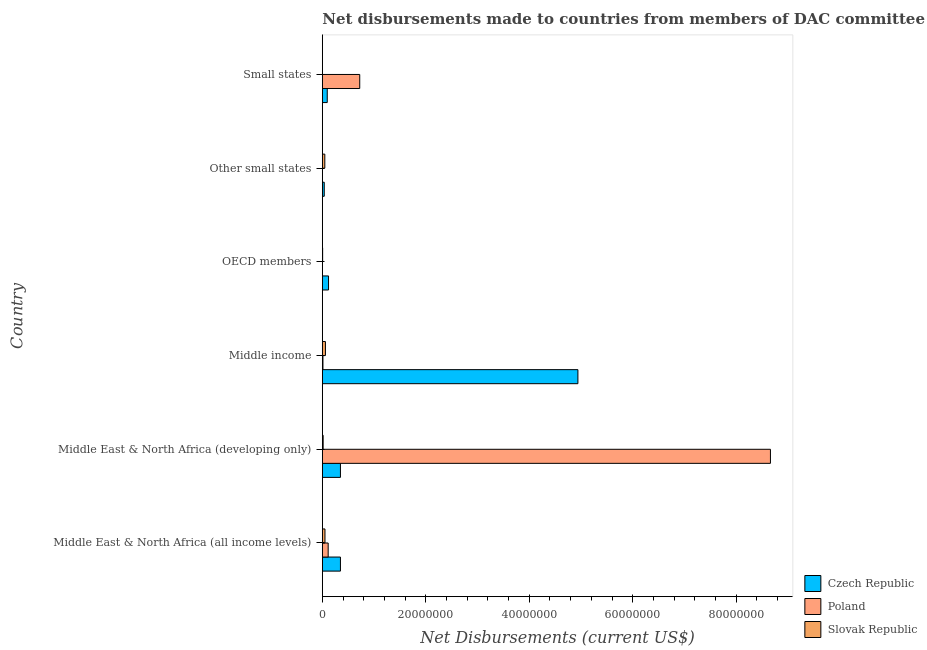How many groups of bars are there?
Your answer should be very brief. 6. Are the number of bars per tick equal to the number of legend labels?
Offer a terse response. No. What is the label of the 5th group of bars from the top?
Make the answer very short. Middle East & North Africa (developing only). In how many cases, is the number of bars for a given country not equal to the number of legend labels?
Your answer should be compact. 2. What is the net disbursements made by slovak republic in Middle East & North Africa (developing only)?
Ensure brevity in your answer.  1.60e+05. Across all countries, what is the maximum net disbursements made by poland?
Give a very brief answer. 8.66e+07. Across all countries, what is the minimum net disbursements made by czech republic?
Provide a succinct answer. 3.70e+05. In which country was the net disbursements made by czech republic maximum?
Provide a succinct answer. Middle income. What is the total net disbursements made by czech republic in the graph?
Make the answer very short. 5.89e+07. What is the difference between the net disbursements made by slovak republic in Middle East & North Africa (all income levels) and that in Small states?
Keep it short and to the point. 4.80e+05. What is the difference between the net disbursements made by poland in Small states and the net disbursements made by slovak republic in Other small states?
Provide a succinct answer. 6.75e+06. What is the average net disbursements made by czech republic per country?
Keep it short and to the point. 9.82e+06. What is the difference between the net disbursements made by slovak republic and net disbursements made by czech republic in Other small states?
Give a very brief answer. 1.10e+05. In how many countries, is the net disbursements made by czech republic greater than 76000000 US$?
Offer a very short reply. 0. What is the ratio of the net disbursements made by slovak republic in Other small states to that in Small states?
Your answer should be very brief. 16. Is the difference between the net disbursements made by poland in Middle East & North Africa (all income levels) and Small states greater than the difference between the net disbursements made by czech republic in Middle East & North Africa (all income levels) and Small states?
Provide a short and direct response. No. What is the difference between the highest and the second highest net disbursements made by poland?
Provide a short and direct response. 7.94e+07. What is the difference between the highest and the lowest net disbursements made by slovak republic?
Your response must be concise. 5.70e+05. Is it the case that in every country, the sum of the net disbursements made by czech republic and net disbursements made by poland is greater than the net disbursements made by slovak republic?
Make the answer very short. No. How many bars are there?
Offer a very short reply. 16. How many countries are there in the graph?
Keep it short and to the point. 6. Does the graph contain any zero values?
Offer a very short reply. Yes. Does the graph contain grids?
Offer a terse response. No. Where does the legend appear in the graph?
Offer a terse response. Bottom right. How many legend labels are there?
Your answer should be very brief. 3. What is the title of the graph?
Your answer should be compact. Net disbursements made to countries from members of DAC committee. Does "Other sectors" appear as one of the legend labels in the graph?
Ensure brevity in your answer.  No. What is the label or title of the X-axis?
Ensure brevity in your answer.  Net Disbursements (current US$). What is the label or title of the Y-axis?
Your response must be concise. Country. What is the Net Disbursements (current US$) of Czech Republic in Middle East & North Africa (all income levels)?
Offer a very short reply. 3.50e+06. What is the Net Disbursements (current US$) in Poland in Middle East & North Africa (all income levels)?
Your response must be concise. 1.13e+06. What is the Net Disbursements (current US$) of Slovak Republic in Middle East & North Africa (all income levels)?
Make the answer very short. 5.10e+05. What is the Net Disbursements (current US$) of Czech Republic in Middle East & North Africa (developing only)?
Your answer should be very brief. 3.50e+06. What is the Net Disbursements (current US$) of Poland in Middle East & North Africa (developing only)?
Give a very brief answer. 8.66e+07. What is the Net Disbursements (current US$) of Czech Republic in Middle income?
Keep it short and to the point. 4.94e+07. What is the Net Disbursements (current US$) in Slovak Republic in Middle income?
Your answer should be very brief. 6.00e+05. What is the Net Disbursements (current US$) of Czech Republic in OECD members?
Make the answer very short. 1.20e+06. What is the Net Disbursements (current US$) of Poland in Other small states?
Ensure brevity in your answer.  0. What is the Net Disbursements (current US$) of Slovak Republic in Other small states?
Provide a short and direct response. 4.80e+05. What is the Net Disbursements (current US$) of Czech Republic in Small states?
Your response must be concise. 9.50e+05. What is the Net Disbursements (current US$) in Poland in Small states?
Your answer should be compact. 7.23e+06. What is the Net Disbursements (current US$) in Slovak Republic in Small states?
Your answer should be very brief. 3.00e+04. Across all countries, what is the maximum Net Disbursements (current US$) in Czech Republic?
Your answer should be compact. 4.94e+07. Across all countries, what is the maximum Net Disbursements (current US$) in Poland?
Ensure brevity in your answer.  8.66e+07. Across all countries, what is the maximum Net Disbursements (current US$) of Slovak Republic?
Provide a short and direct response. 6.00e+05. Across all countries, what is the minimum Net Disbursements (current US$) of Poland?
Make the answer very short. 0. What is the total Net Disbursements (current US$) of Czech Republic in the graph?
Keep it short and to the point. 5.89e+07. What is the total Net Disbursements (current US$) of Poland in the graph?
Provide a succinct answer. 9.51e+07. What is the total Net Disbursements (current US$) of Slovak Republic in the graph?
Give a very brief answer. 1.84e+06. What is the difference between the Net Disbursements (current US$) of Czech Republic in Middle East & North Africa (all income levels) and that in Middle East & North Africa (developing only)?
Keep it short and to the point. 0. What is the difference between the Net Disbursements (current US$) of Poland in Middle East & North Africa (all income levels) and that in Middle East & North Africa (developing only)?
Your answer should be very brief. -8.55e+07. What is the difference between the Net Disbursements (current US$) in Czech Republic in Middle East & North Africa (all income levels) and that in Middle income?
Provide a succinct answer. -4.59e+07. What is the difference between the Net Disbursements (current US$) of Poland in Middle East & North Africa (all income levels) and that in Middle income?
Your response must be concise. 1.01e+06. What is the difference between the Net Disbursements (current US$) in Slovak Republic in Middle East & North Africa (all income levels) and that in Middle income?
Your answer should be compact. -9.00e+04. What is the difference between the Net Disbursements (current US$) in Czech Republic in Middle East & North Africa (all income levels) and that in OECD members?
Your answer should be very brief. 2.30e+06. What is the difference between the Net Disbursements (current US$) in Czech Republic in Middle East & North Africa (all income levels) and that in Other small states?
Ensure brevity in your answer.  3.13e+06. What is the difference between the Net Disbursements (current US$) of Slovak Republic in Middle East & North Africa (all income levels) and that in Other small states?
Offer a very short reply. 3.00e+04. What is the difference between the Net Disbursements (current US$) of Czech Republic in Middle East & North Africa (all income levels) and that in Small states?
Make the answer very short. 2.55e+06. What is the difference between the Net Disbursements (current US$) in Poland in Middle East & North Africa (all income levels) and that in Small states?
Offer a terse response. -6.10e+06. What is the difference between the Net Disbursements (current US$) of Czech Republic in Middle East & North Africa (developing only) and that in Middle income?
Provide a short and direct response. -4.59e+07. What is the difference between the Net Disbursements (current US$) of Poland in Middle East & North Africa (developing only) and that in Middle income?
Your response must be concise. 8.65e+07. What is the difference between the Net Disbursements (current US$) of Slovak Republic in Middle East & North Africa (developing only) and that in Middle income?
Your answer should be compact. -4.40e+05. What is the difference between the Net Disbursements (current US$) of Czech Republic in Middle East & North Africa (developing only) and that in OECD members?
Keep it short and to the point. 2.30e+06. What is the difference between the Net Disbursements (current US$) in Slovak Republic in Middle East & North Africa (developing only) and that in OECD members?
Give a very brief answer. 1.00e+05. What is the difference between the Net Disbursements (current US$) of Czech Republic in Middle East & North Africa (developing only) and that in Other small states?
Provide a succinct answer. 3.13e+06. What is the difference between the Net Disbursements (current US$) of Slovak Republic in Middle East & North Africa (developing only) and that in Other small states?
Offer a terse response. -3.20e+05. What is the difference between the Net Disbursements (current US$) of Czech Republic in Middle East & North Africa (developing only) and that in Small states?
Your response must be concise. 2.55e+06. What is the difference between the Net Disbursements (current US$) in Poland in Middle East & North Africa (developing only) and that in Small states?
Your answer should be compact. 7.94e+07. What is the difference between the Net Disbursements (current US$) in Slovak Republic in Middle East & North Africa (developing only) and that in Small states?
Provide a short and direct response. 1.30e+05. What is the difference between the Net Disbursements (current US$) in Czech Republic in Middle income and that in OECD members?
Give a very brief answer. 4.82e+07. What is the difference between the Net Disbursements (current US$) of Slovak Republic in Middle income and that in OECD members?
Your answer should be compact. 5.40e+05. What is the difference between the Net Disbursements (current US$) of Czech Republic in Middle income and that in Other small states?
Give a very brief answer. 4.90e+07. What is the difference between the Net Disbursements (current US$) in Slovak Republic in Middle income and that in Other small states?
Offer a terse response. 1.20e+05. What is the difference between the Net Disbursements (current US$) of Czech Republic in Middle income and that in Small states?
Make the answer very short. 4.84e+07. What is the difference between the Net Disbursements (current US$) of Poland in Middle income and that in Small states?
Provide a succinct answer. -7.11e+06. What is the difference between the Net Disbursements (current US$) of Slovak Republic in Middle income and that in Small states?
Your answer should be compact. 5.70e+05. What is the difference between the Net Disbursements (current US$) of Czech Republic in OECD members and that in Other small states?
Your answer should be very brief. 8.30e+05. What is the difference between the Net Disbursements (current US$) in Slovak Republic in OECD members and that in Other small states?
Keep it short and to the point. -4.20e+05. What is the difference between the Net Disbursements (current US$) in Czech Republic in OECD members and that in Small states?
Your answer should be very brief. 2.50e+05. What is the difference between the Net Disbursements (current US$) in Slovak Republic in OECD members and that in Small states?
Provide a succinct answer. 3.00e+04. What is the difference between the Net Disbursements (current US$) in Czech Republic in Other small states and that in Small states?
Your response must be concise. -5.80e+05. What is the difference between the Net Disbursements (current US$) of Slovak Republic in Other small states and that in Small states?
Offer a very short reply. 4.50e+05. What is the difference between the Net Disbursements (current US$) in Czech Republic in Middle East & North Africa (all income levels) and the Net Disbursements (current US$) in Poland in Middle East & North Africa (developing only)?
Keep it short and to the point. -8.31e+07. What is the difference between the Net Disbursements (current US$) of Czech Republic in Middle East & North Africa (all income levels) and the Net Disbursements (current US$) of Slovak Republic in Middle East & North Africa (developing only)?
Provide a succinct answer. 3.34e+06. What is the difference between the Net Disbursements (current US$) of Poland in Middle East & North Africa (all income levels) and the Net Disbursements (current US$) of Slovak Republic in Middle East & North Africa (developing only)?
Give a very brief answer. 9.70e+05. What is the difference between the Net Disbursements (current US$) of Czech Republic in Middle East & North Africa (all income levels) and the Net Disbursements (current US$) of Poland in Middle income?
Your answer should be very brief. 3.38e+06. What is the difference between the Net Disbursements (current US$) in Czech Republic in Middle East & North Africa (all income levels) and the Net Disbursements (current US$) in Slovak Republic in Middle income?
Provide a short and direct response. 2.90e+06. What is the difference between the Net Disbursements (current US$) of Poland in Middle East & North Africa (all income levels) and the Net Disbursements (current US$) of Slovak Republic in Middle income?
Keep it short and to the point. 5.30e+05. What is the difference between the Net Disbursements (current US$) of Czech Republic in Middle East & North Africa (all income levels) and the Net Disbursements (current US$) of Slovak Republic in OECD members?
Offer a very short reply. 3.44e+06. What is the difference between the Net Disbursements (current US$) in Poland in Middle East & North Africa (all income levels) and the Net Disbursements (current US$) in Slovak Republic in OECD members?
Your answer should be very brief. 1.07e+06. What is the difference between the Net Disbursements (current US$) in Czech Republic in Middle East & North Africa (all income levels) and the Net Disbursements (current US$) in Slovak Republic in Other small states?
Offer a very short reply. 3.02e+06. What is the difference between the Net Disbursements (current US$) of Poland in Middle East & North Africa (all income levels) and the Net Disbursements (current US$) of Slovak Republic in Other small states?
Your answer should be compact. 6.50e+05. What is the difference between the Net Disbursements (current US$) in Czech Republic in Middle East & North Africa (all income levels) and the Net Disbursements (current US$) in Poland in Small states?
Offer a very short reply. -3.73e+06. What is the difference between the Net Disbursements (current US$) of Czech Republic in Middle East & North Africa (all income levels) and the Net Disbursements (current US$) of Slovak Republic in Small states?
Provide a succinct answer. 3.47e+06. What is the difference between the Net Disbursements (current US$) in Poland in Middle East & North Africa (all income levels) and the Net Disbursements (current US$) in Slovak Republic in Small states?
Your answer should be compact. 1.10e+06. What is the difference between the Net Disbursements (current US$) of Czech Republic in Middle East & North Africa (developing only) and the Net Disbursements (current US$) of Poland in Middle income?
Your answer should be very brief. 3.38e+06. What is the difference between the Net Disbursements (current US$) in Czech Republic in Middle East & North Africa (developing only) and the Net Disbursements (current US$) in Slovak Republic in Middle income?
Your answer should be compact. 2.90e+06. What is the difference between the Net Disbursements (current US$) of Poland in Middle East & North Africa (developing only) and the Net Disbursements (current US$) of Slovak Republic in Middle income?
Keep it short and to the point. 8.60e+07. What is the difference between the Net Disbursements (current US$) of Czech Republic in Middle East & North Africa (developing only) and the Net Disbursements (current US$) of Slovak Republic in OECD members?
Give a very brief answer. 3.44e+06. What is the difference between the Net Disbursements (current US$) of Poland in Middle East & North Africa (developing only) and the Net Disbursements (current US$) of Slovak Republic in OECD members?
Your answer should be compact. 8.66e+07. What is the difference between the Net Disbursements (current US$) of Czech Republic in Middle East & North Africa (developing only) and the Net Disbursements (current US$) of Slovak Republic in Other small states?
Offer a very short reply. 3.02e+06. What is the difference between the Net Disbursements (current US$) of Poland in Middle East & North Africa (developing only) and the Net Disbursements (current US$) of Slovak Republic in Other small states?
Provide a succinct answer. 8.61e+07. What is the difference between the Net Disbursements (current US$) of Czech Republic in Middle East & North Africa (developing only) and the Net Disbursements (current US$) of Poland in Small states?
Keep it short and to the point. -3.73e+06. What is the difference between the Net Disbursements (current US$) in Czech Republic in Middle East & North Africa (developing only) and the Net Disbursements (current US$) in Slovak Republic in Small states?
Make the answer very short. 3.47e+06. What is the difference between the Net Disbursements (current US$) in Poland in Middle East & North Africa (developing only) and the Net Disbursements (current US$) in Slovak Republic in Small states?
Offer a very short reply. 8.66e+07. What is the difference between the Net Disbursements (current US$) in Czech Republic in Middle income and the Net Disbursements (current US$) in Slovak Republic in OECD members?
Your response must be concise. 4.93e+07. What is the difference between the Net Disbursements (current US$) of Czech Republic in Middle income and the Net Disbursements (current US$) of Slovak Republic in Other small states?
Offer a very short reply. 4.89e+07. What is the difference between the Net Disbursements (current US$) of Poland in Middle income and the Net Disbursements (current US$) of Slovak Republic in Other small states?
Provide a succinct answer. -3.60e+05. What is the difference between the Net Disbursements (current US$) of Czech Republic in Middle income and the Net Disbursements (current US$) of Poland in Small states?
Your response must be concise. 4.22e+07. What is the difference between the Net Disbursements (current US$) in Czech Republic in Middle income and the Net Disbursements (current US$) in Slovak Republic in Small states?
Your answer should be compact. 4.94e+07. What is the difference between the Net Disbursements (current US$) of Poland in Middle income and the Net Disbursements (current US$) of Slovak Republic in Small states?
Make the answer very short. 9.00e+04. What is the difference between the Net Disbursements (current US$) in Czech Republic in OECD members and the Net Disbursements (current US$) in Slovak Republic in Other small states?
Offer a terse response. 7.20e+05. What is the difference between the Net Disbursements (current US$) of Czech Republic in OECD members and the Net Disbursements (current US$) of Poland in Small states?
Keep it short and to the point. -6.03e+06. What is the difference between the Net Disbursements (current US$) in Czech Republic in OECD members and the Net Disbursements (current US$) in Slovak Republic in Small states?
Ensure brevity in your answer.  1.17e+06. What is the difference between the Net Disbursements (current US$) in Czech Republic in Other small states and the Net Disbursements (current US$) in Poland in Small states?
Your answer should be compact. -6.86e+06. What is the average Net Disbursements (current US$) in Czech Republic per country?
Provide a short and direct response. 9.82e+06. What is the average Net Disbursements (current US$) in Poland per country?
Ensure brevity in your answer.  1.58e+07. What is the average Net Disbursements (current US$) in Slovak Republic per country?
Your answer should be compact. 3.07e+05. What is the difference between the Net Disbursements (current US$) of Czech Republic and Net Disbursements (current US$) of Poland in Middle East & North Africa (all income levels)?
Give a very brief answer. 2.37e+06. What is the difference between the Net Disbursements (current US$) in Czech Republic and Net Disbursements (current US$) in Slovak Republic in Middle East & North Africa (all income levels)?
Your response must be concise. 2.99e+06. What is the difference between the Net Disbursements (current US$) of Poland and Net Disbursements (current US$) of Slovak Republic in Middle East & North Africa (all income levels)?
Give a very brief answer. 6.20e+05. What is the difference between the Net Disbursements (current US$) of Czech Republic and Net Disbursements (current US$) of Poland in Middle East & North Africa (developing only)?
Make the answer very short. -8.31e+07. What is the difference between the Net Disbursements (current US$) in Czech Republic and Net Disbursements (current US$) in Slovak Republic in Middle East & North Africa (developing only)?
Offer a terse response. 3.34e+06. What is the difference between the Net Disbursements (current US$) in Poland and Net Disbursements (current US$) in Slovak Republic in Middle East & North Africa (developing only)?
Give a very brief answer. 8.64e+07. What is the difference between the Net Disbursements (current US$) of Czech Republic and Net Disbursements (current US$) of Poland in Middle income?
Your answer should be very brief. 4.93e+07. What is the difference between the Net Disbursements (current US$) in Czech Republic and Net Disbursements (current US$) in Slovak Republic in Middle income?
Your answer should be compact. 4.88e+07. What is the difference between the Net Disbursements (current US$) of Poland and Net Disbursements (current US$) of Slovak Republic in Middle income?
Offer a very short reply. -4.80e+05. What is the difference between the Net Disbursements (current US$) of Czech Republic and Net Disbursements (current US$) of Slovak Republic in OECD members?
Provide a short and direct response. 1.14e+06. What is the difference between the Net Disbursements (current US$) of Czech Republic and Net Disbursements (current US$) of Poland in Small states?
Offer a very short reply. -6.28e+06. What is the difference between the Net Disbursements (current US$) of Czech Republic and Net Disbursements (current US$) of Slovak Republic in Small states?
Your response must be concise. 9.20e+05. What is the difference between the Net Disbursements (current US$) in Poland and Net Disbursements (current US$) in Slovak Republic in Small states?
Ensure brevity in your answer.  7.20e+06. What is the ratio of the Net Disbursements (current US$) of Czech Republic in Middle East & North Africa (all income levels) to that in Middle East & North Africa (developing only)?
Make the answer very short. 1. What is the ratio of the Net Disbursements (current US$) of Poland in Middle East & North Africa (all income levels) to that in Middle East & North Africa (developing only)?
Offer a terse response. 0.01. What is the ratio of the Net Disbursements (current US$) of Slovak Republic in Middle East & North Africa (all income levels) to that in Middle East & North Africa (developing only)?
Your answer should be compact. 3.19. What is the ratio of the Net Disbursements (current US$) in Czech Republic in Middle East & North Africa (all income levels) to that in Middle income?
Your answer should be compact. 0.07. What is the ratio of the Net Disbursements (current US$) in Poland in Middle East & North Africa (all income levels) to that in Middle income?
Provide a succinct answer. 9.42. What is the ratio of the Net Disbursements (current US$) in Slovak Republic in Middle East & North Africa (all income levels) to that in Middle income?
Provide a succinct answer. 0.85. What is the ratio of the Net Disbursements (current US$) in Czech Republic in Middle East & North Africa (all income levels) to that in OECD members?
Your answer should be very brief. 2.92. What is the ratio of the Net Disbursements (current US$) in Czech Republic in Middle East & North Africa (all income levels) to that in Other small states?
Ensure brevity in your answer.  9.46. What is the ratio of the Net Disbursements (current US$) of Czech Republic in Middle East & North Africa (all income levels) to that in Small states?
Give a very brief answer. 3.68. What is the ratio of the Net Disbursements (current US$) in Poland in Middle East & North Africa (all income levels) to that in Small states?
Provide a succinct answer. 0.16. What is the ratio of the Net Disbursements (current US$) in Czech Republic in Middle East & North Africa (developing only) to that in Middle income?
Keep it short and to the point. 0.07. What is the ratio of the Net Disbursements (current US$) in Poland in Middle East & North Africa (developing only) to that in Middle income?
Provide a succinct answer. 721.75. What is the ratio of the Net Disbursements (current US$) in Slovak Republic in Middle East & North Africa (developing only) to that in Middle income?
Provide a succinct answer. 0.27. What is the ratio of the Net Disbursements (current US$) of Czech Republic in Middle East & North Africa (developing only) to that in OECD members?
Your response must be concise. 2.92. What is the ratio of the Net Disbursements (current US$) in Slovak Republic in Middle East & North Africa (developing only) to that in OECD members?
Make the answer very short. 2.67. What is the ratio of the Net Disbursements (current US$) of Czech Republic in Middle East & North Africa (developing only) to that in Other small states?
Your response must be concise. 9.46. What is the ratio of the Net Disbursements (current US$) in Slovak Republic in Middle East & North Africa (developing only) to that in Other small states?
Make the answer very short. 0.33. What is the ratio of the Net Disbursements (current US$) in Czech Republic in Middle East & North Africa (developing only) to that in Small states?
Keep it short and to the point. 3.68. What is the ratio of the Net Disbursements (current US$) in Poland in Middle East & North Africa (developing only) to that in Small states?
Ensure brevity in your answer.  11.98. What is the ratio of the Net Disbursements (current US$) in Slovak Republic in Middle East & North Africa (developing only) to that in Small states?
Provide a short and direct response. 5.33. What is the ratio of the Net Disbursements (current US$) of Czech Republic in Middle income to that in OECD members?
Your answer should be compact. 41.17. What is the ratio of the Net Disbursements (current US$) in Slovak Republic in Middle income to that in OECD members?
Ensure brevity in your answer.  10. What is the ratio of the Net Disbursements (current US$) of Czech Republic in Middle income to that in Other small states?
Keep it short and to the point. 133.51. What is the ratio of the Net Disbursements (current US$) of Slovak Republic in Middle income to that in Other small states?
Offer a terse response. 1.25. What is the ratio of the Net Disbursements (current US$) of Czech Republic in Middle income to that in Small states?
Offer a terse response. 52. What is the ratio of the Net Disbursements (current US$) of Poland in Middle income to that in Small states?
Offer a very short reply. 0.02. What is the ratio of the Net Disbursements (current US$) in Czech Republic in OECD members to that in Other small states?
Ensure brevity in your answer.  3.24. What is the ratio of the Net Disbursements (current US$) in Czech Republic in OECD members to that in Small states?
Keep it short and to the point. 1.26. What is the ratio of the Net Disbursements (current US$) of Czech Republic in Other small states to that in Small states?
Provide a succinct answer. 0.39. What is the difference between the highest and the second highest Net Disbursements (current US$) in Czech Republic?
Offer a terse response. 4.59e+07. What is the difference between the highest and the second highest Net Disbursements (current US$) of Poland?
Your answer should be compact. 7.94e+07. What is the difference between the highest and the second highest Net Disbursements (current US$) in Slovak Republic?
Your response must be concise. 9.00e+04. What is the difference between the highest and the lowest Net Disbursements (current US$) of Czech Republic?
Your response must be concise. 4.90e+07. What is the difference between the highest and the lowest Net Disbursements (current US$) of Poland?
Your answer should be very brief. 8.66e+07. What is the difference between the highest and the lowest Net Disbursements (current US$) in Slovak Republic?
Offer a terse response. 5.70e+05. 